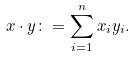Convert formula to latex. <formula><loc_0><loc_0><loc_500><loc_500>x \cdot y \colon = \sum _ { i = 1 } ^ { n } x _ { i } y _ { i } .</formula> 